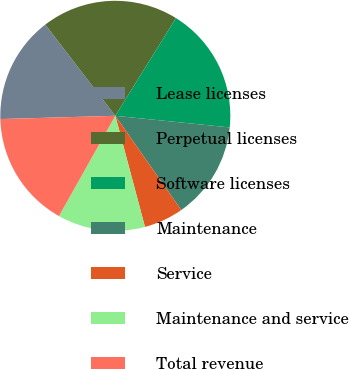Convert chart. <chart><loc_0><loc_0><loc_500><loc_500><pie_chart><fcel>Lease licenses<fcel>Perpetual licenses<fcel>Software licenses<fcel>Maintenance<fcel>Service<fcel>Maintenance and service<fcel>Total revenue<nl><fcel>15.03%<fcel>19.26%<fcel>17.77%<fcel>13.67%<fcel>5.57%<fcel>12.3%<fcel>16.4%<nl></chart> 